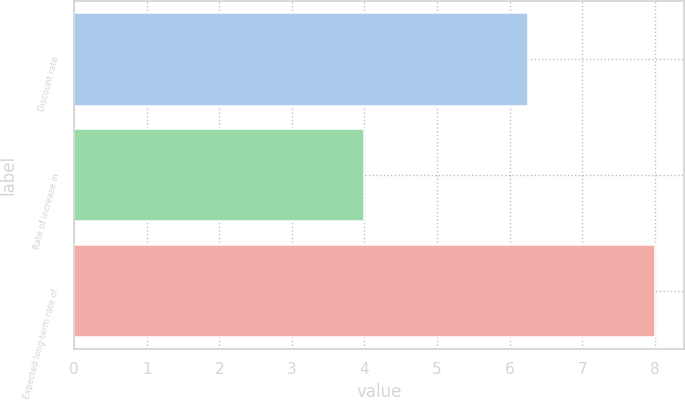<chart> <loc_0><loc_0><loc_500><loc_500><bar_chart><fcel>Discount rate<fcel>Rate of increase in<fcel>Expected long-term rate of<nl><fcel>6.25<fcel>4<fcel>8<nl></chart> 